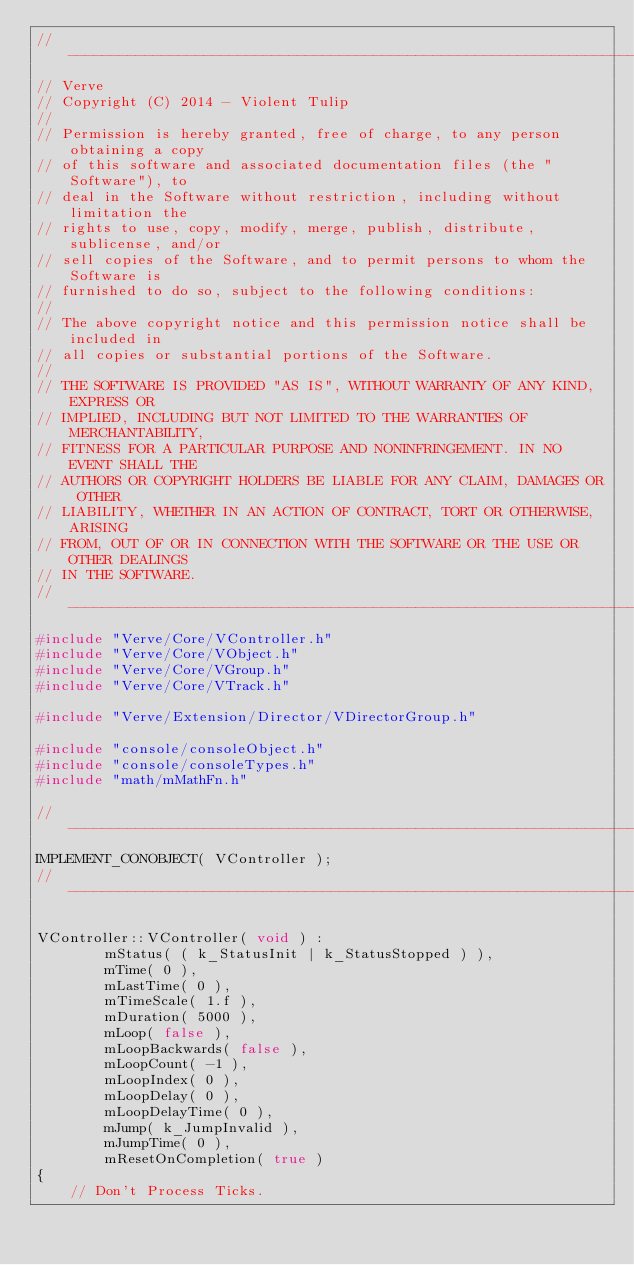<code> <loc_0><loc_0><loc_500><loc_500><_C++_>//-----------------------------------------------------------------------------
// Verve
// Copyright (C) 2014 - Violent Tulip
//
// Permission is hereby granted, free of charge, to any person obtaining a copy
// of this software and associated documentation files (the "Software"), to
// deal in the Software without restriction, including without limitation the
// rights to use, copy, modify, merge, publish, distribute, sublicense, and/or
// sell copies of the Software, and to permit persons to whom the Software is
// furnished to do so, subject to the following conditions:
//
// The above copyright notice and this permission notice shall be included in
// all copies or substantial portions of the Software.
//
// THE SOFTWARE IS PROVIDED "AS IS", WITHOUT WARRANTY OF ANY KIND, EXPRESS OR
// IMPLIED, INCLUDING BUT NOT LIMITED TO THE WARRANTIES OF MERCHANTABILITY,
// FITNESS FOR A PARTICULAR PURPOSE AND NONINFRINGEMENT. IN NO EVENT SHALL THE
// AUTHORS OR COPYRIGHT HOLDERS BE LIABLE FOR ANY CLAIM, DAMAGES OR OTHER
// LIABILITY, WHETHER IN AN ACTION OF CONTRACT, TORT OR OTHERWISE, ARISING
// FROM, OUT OF OR IN CONNECTION WITH THE SOFTWARE OR THE USE OR OTHER DEALINGS
// IN THE SOFTWARE.
//-----------------------------------------------------------------------------
#include "Verve/Core/VController.h"
#include "Verve/Core/VObject.h"
#include "Verve/Core/VGroup.h"
#include "Verve/Core/VTrack.h"

#include "Verve/Extension/Director/VDirectorGroup.h"

#include "console/consoleObject.h"
#include "console/consoleTypes.h"
#include "math/mMathFn.h"

//-----------------------------------------------------------------------------
IMPLEMENT_CONOBJECT( VController );
//-----------------------------------------------------------------------------

VController::VController( void ) :
        mStatus( ( k_StatusInit | k_StatusStopped ) ),
        mTime( 0 ),
        mLastTime( 0 ),
        mTimeScale( 1.f ),
        mDuration( 5000 ),
        mLoop( false ),
        mLoopBackwards( false ),
        mLoopCount( -1 ),
        mLoopIndex( 0 ),
        mLoopDelay( 0 ),
        mLoopDelayTime( 0 ),
        mJump( k_JumpInvalid ),
        mJumpTime( 0 ),
        mResetOnCompletion( true )
{
    // Don't Process Ticks.</code> 